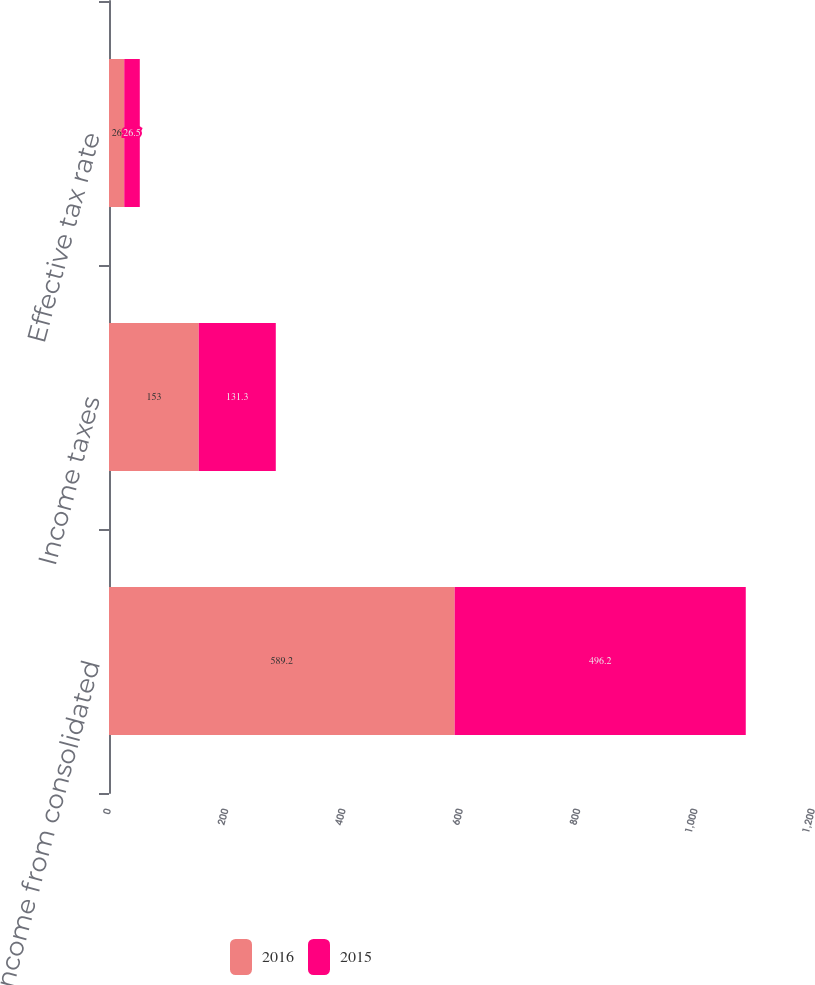<chart> <loc_0><loc_0><loc_500><loc_500><stacked_bar_chart><ecel><fcel>Income from consolidated<fcel>Income taxes<fcel>Effective tax rate<nl><fcel>2016<fcel>589.2<fcel>153<fcel>26<nl><fcel>2015<fcel>496.2<fcel>131.3<fcel>26.5<nl></chart> 